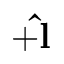Convert formula to latex. <formula><loc_0><loc_0><loc_500><loc_500>+ \hat { l }</formula> 